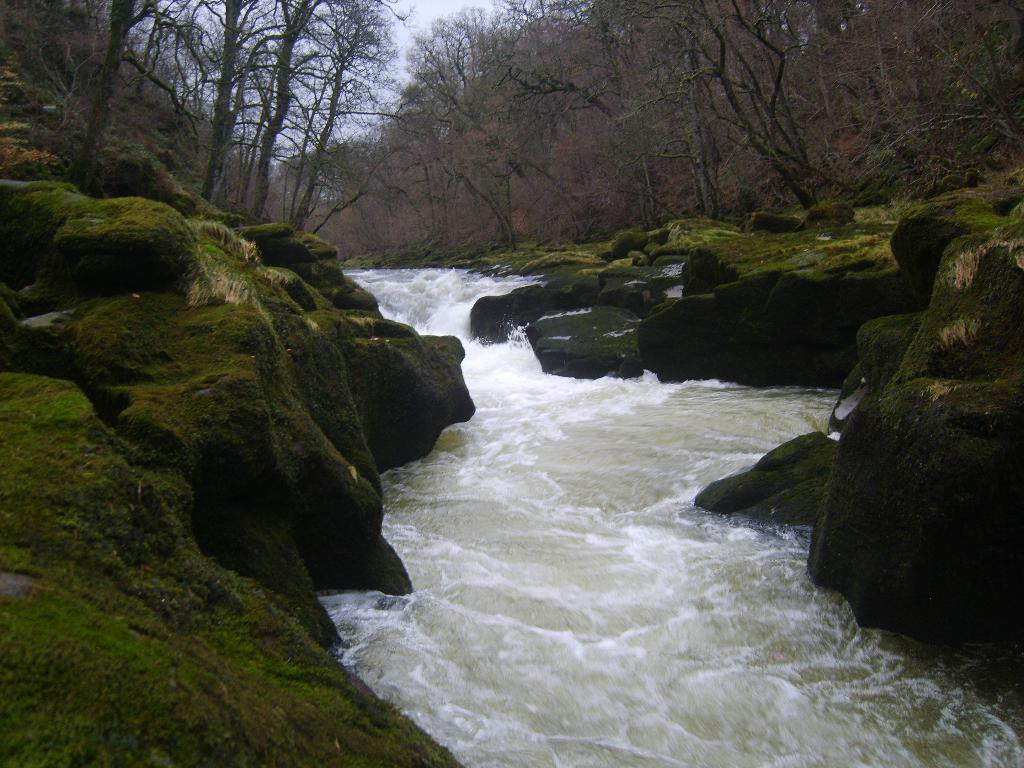What is the main element in the image? There is water in the image. How is the water situated in the image? The water is between rocks. What other natural elements can be seen in the image? There are trees and grass in the image. What part of the natural environment is visible in the image? The sky is visible in the image. What verse can be heard recited by the giraffe in the image? There is no giraffe present in the image, and therefore no verse can be heard. 